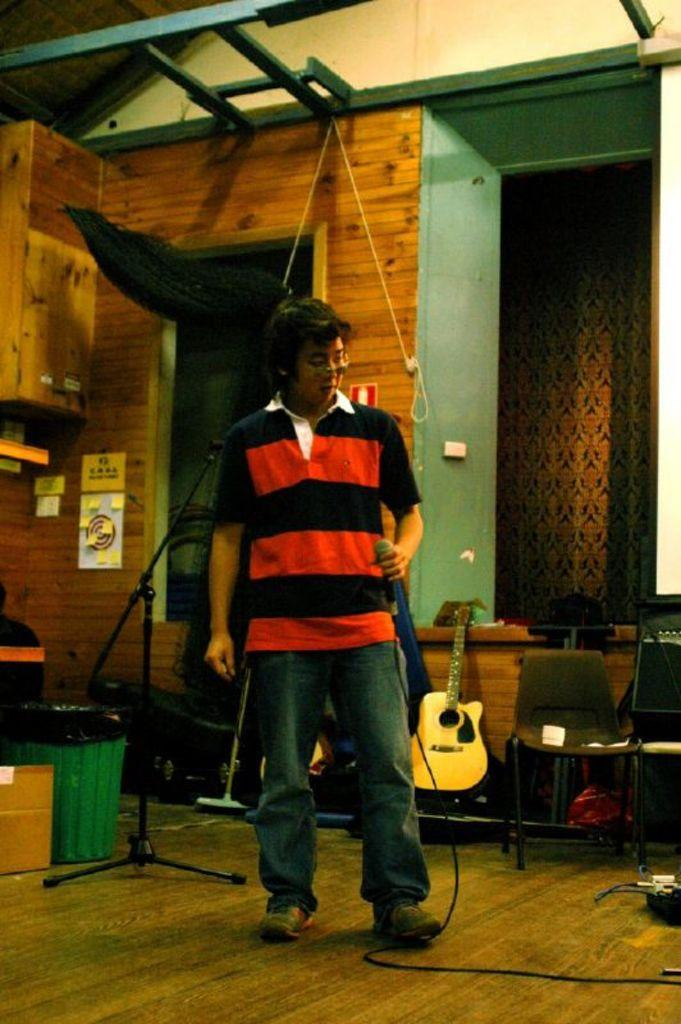What is the main subject of the image? There is a man in the image. What is the man doing with his left hand? The man is holding an object with his left hand. What direction is the man looking in? The man is looking at the floor. What can be seen in the background of the image? There is a wooden wall in the background of the image. What type of bait is the man using in the image? There is no bait present in the image; the man is holding an unspecified object. What kind of leather is visible on the man's clothing in the image? There is no leather visible on the man's clothing in the image. 